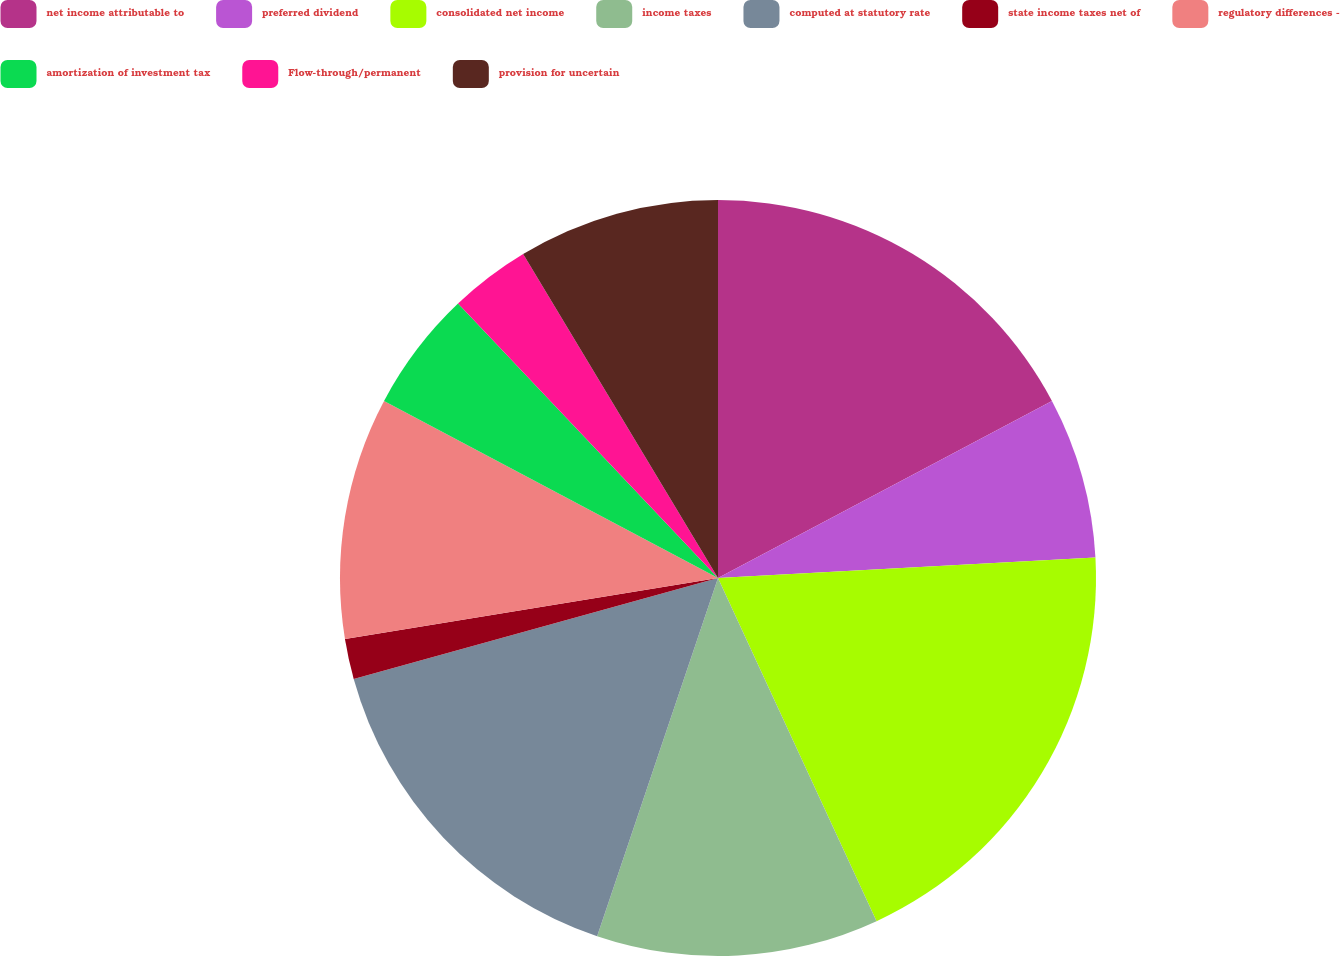Convert chart to OTSL. <chart><loc_0><loc_0><loc_500><loc_500><pie_chart><fcel>net income attributable to<fcel>preferred dividend<fcel>consolidated net income<fcel>income taxes<fcel>computed at statutory rate<fcel>state income taxes net of<fcel>regulatory differences -<fcel>amortization of investment tax<fcel>Flow-through/permanent<fcel>provision for uncertain<nl><fcel>17.24%<fcel>6.9%<fcel>18.97%<fcel>12.07%<fcel>15.52%<fcel>1.72%<fcel>10.34%<fcel>5.17%<fcel>3.45%<fcel>8.62%<nl></chart> 